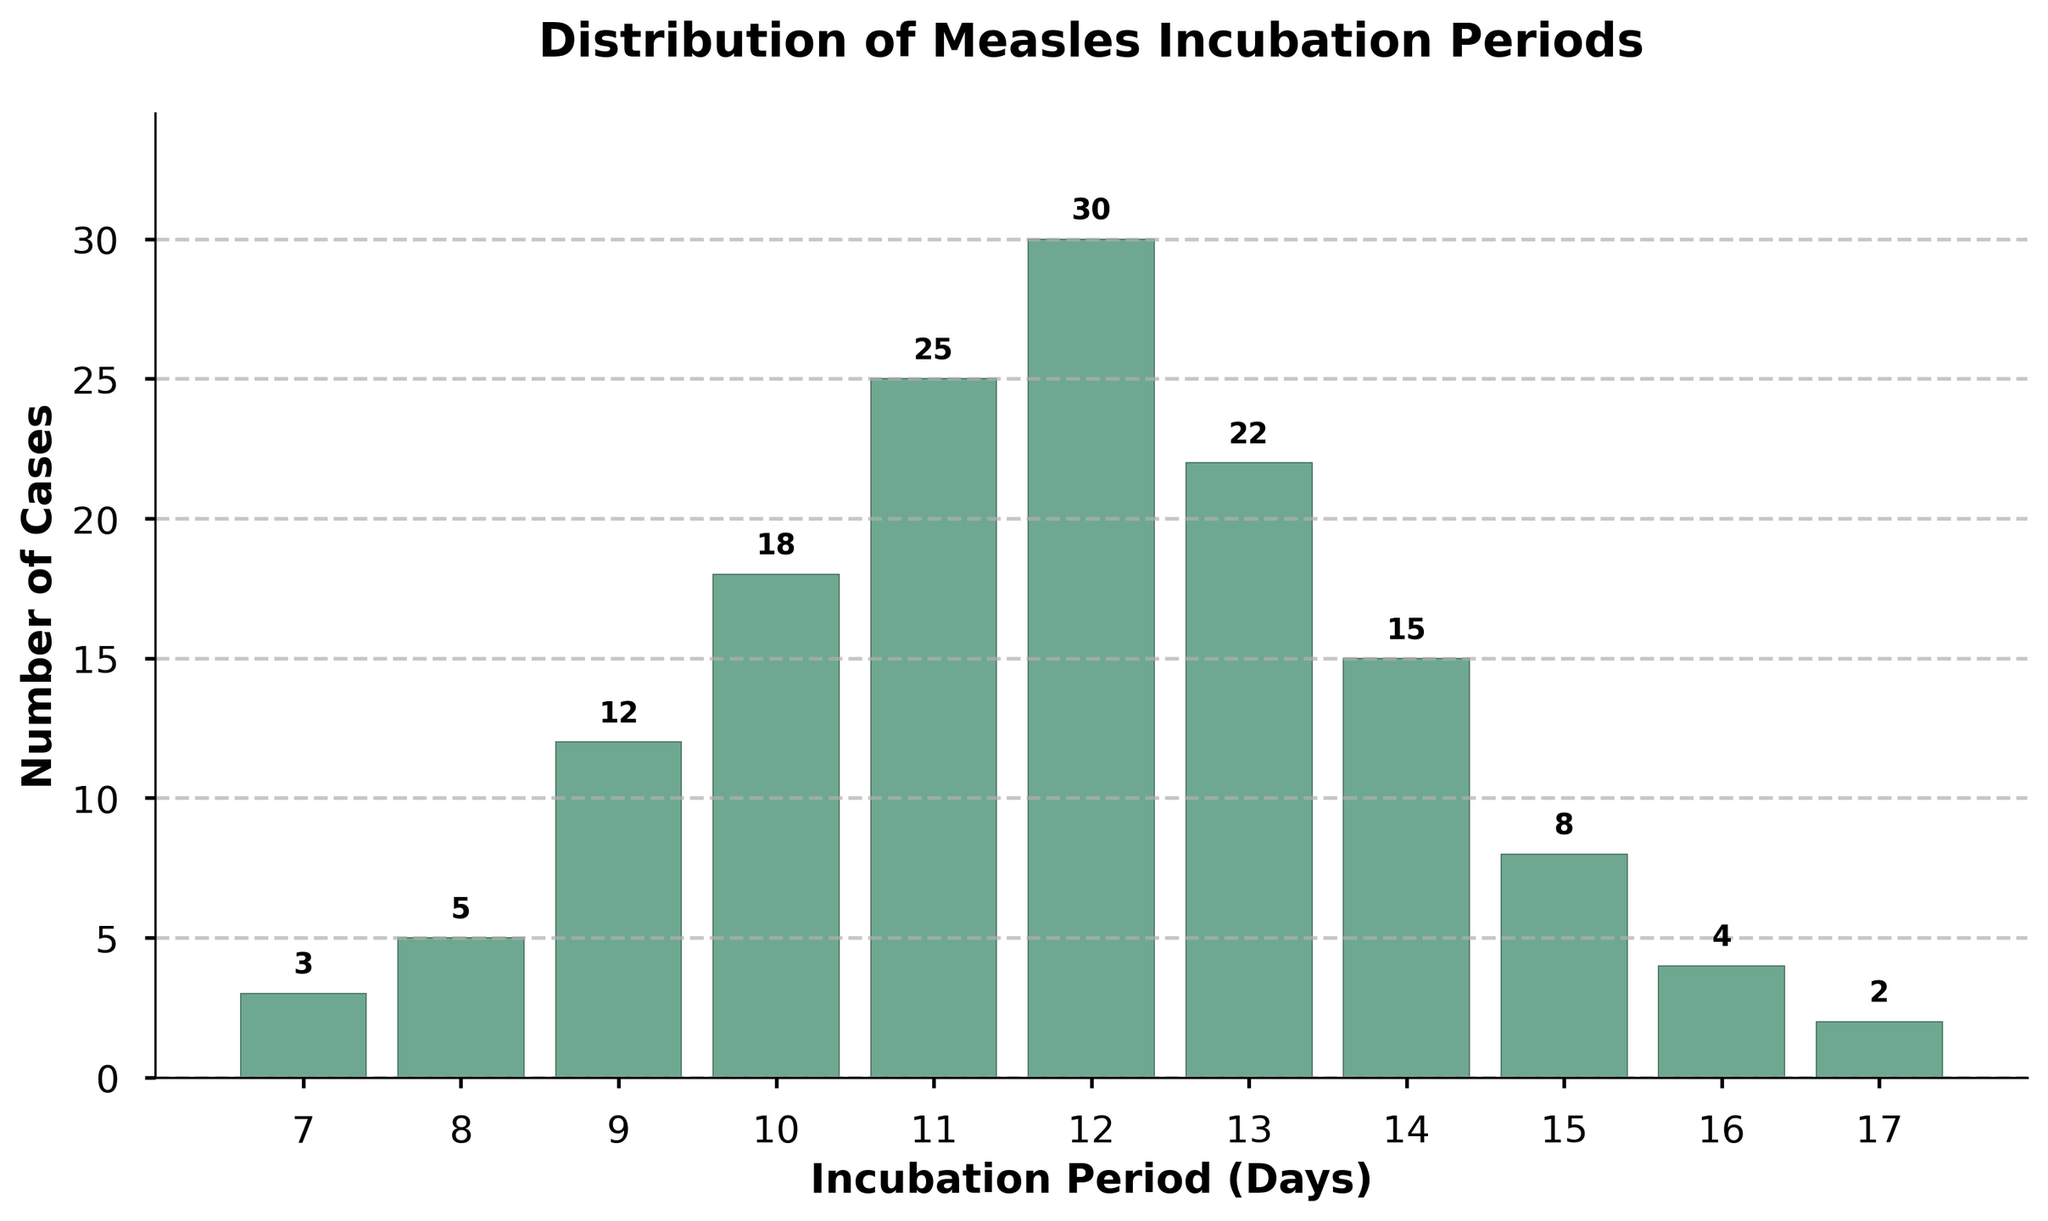What's the highest number of cases observed for any incubation period? The peak of the histogram represents the highest number of cases. Looking at the figure, the bar for the incubation period of 12 days stands the tallest.
Answer: 30 How many incubation periods have fewer than 10 cases? Count the bars that have a height representing fewer than 10 cases. These are for incubation periods 7, 8, 15, 16, and 17 days.
Answer: 5 What is the total number of cases in the dataset? Sum the heights of all bars representing the number of cases. 3 + 5 + 12 + 18 + 25 + 30 + 22 + 15 + 8 + 4 + 2 = 144.
Answer: 144 Which incubation period has the second highest number of cases? By examining the heights of the bars, the highest number of cases is 30 for 12 days, and the second highest is 25 for 11 days.
Answer: 11 days What's the average number of cases for incubation periods 10, 11, and 12 days? Sum the cases for these three periods and divide by 3. The sum is 18 + 25 + 30 = 73. Thus, 73 ÷ 3 = 24.33.
Answer: 24.33 How many more cases are there for an incubation period of 12 days compared to 10 days? Subtract the number of cases for 10 days from that for 12 days. 30 - 18 = 12.
Answer: 12 What is the range of incubation periods presented in the histogram? Identify the smallest and largest incubation period values. The range is from 7 to 17 days.
Answer: 7 to 17 days Which incubation periods have more than 20 cases? Find the bars that exceed the height corresponding to 20 cases. These are 11, 12, and 13 days.
Answer: 11, 12, 13 days How does the number of cases for an incubation period of 14 days compare to that for 15 days? Compare the heights of the bars for these two periods. 14 days has 15 cases, and 15 days has 8 cases. 15 days has fewer cases.
Answer: 15 days has fewer cases What's the median number of cases for the given incubation periods? Order the number of cases and find the middle value. Ordered cases: 2, 3, 4, 5, 8, 12, 15, 18, 22, 25, 30. The median is 15, the middle value.
Answer: 15 